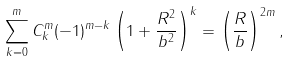<formula> <loc_0><loc_0><loc_500><loc_500>\sum _ { k = 0 } ^ { m } C ^ { m } _ { k } ( - 1 ) ^ { m - k } \left ( 1 + \frac { R ^ { 2 } } { b ^ { 2 } } \right ) ^ { k } = \left ( \frac { R } { b } \right ) ^ { 2 m } ,</formula> 